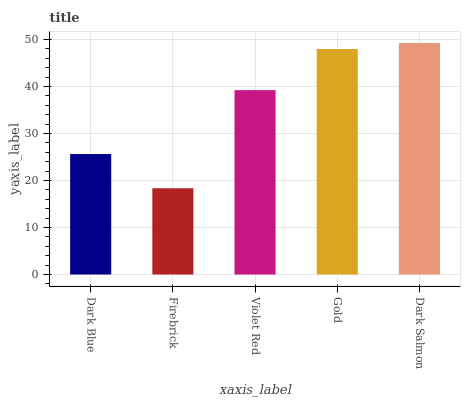Is Firebrick the minimum?
Answer yes or no. Yes. Is Dark Salmon the maximum?
Answer yes or no. Yes. Is Violet Red the minimum?
Answer yes or no. No. Is Violet Red the maximum?
Answer yes or no. No. Is Violet Red greater than Firebrick?
Answer yes or no. Yes. Is Firebrick less than Violet Red?
Answer yes or no. Yes. Is Firebrick greater than Violet Red?
Answer yes or no. No. Is Violet Red less than Firebrick?
Answer yes or no. No. Is Violet Red the high median?
Answer yes or no. Yes. Is Violet Red the low median?
Answer yes or no. Yes. Is Gold the high median?
Answer yes or no. No. Is Dark Salmon the low median?
Answer yes or no. No. 